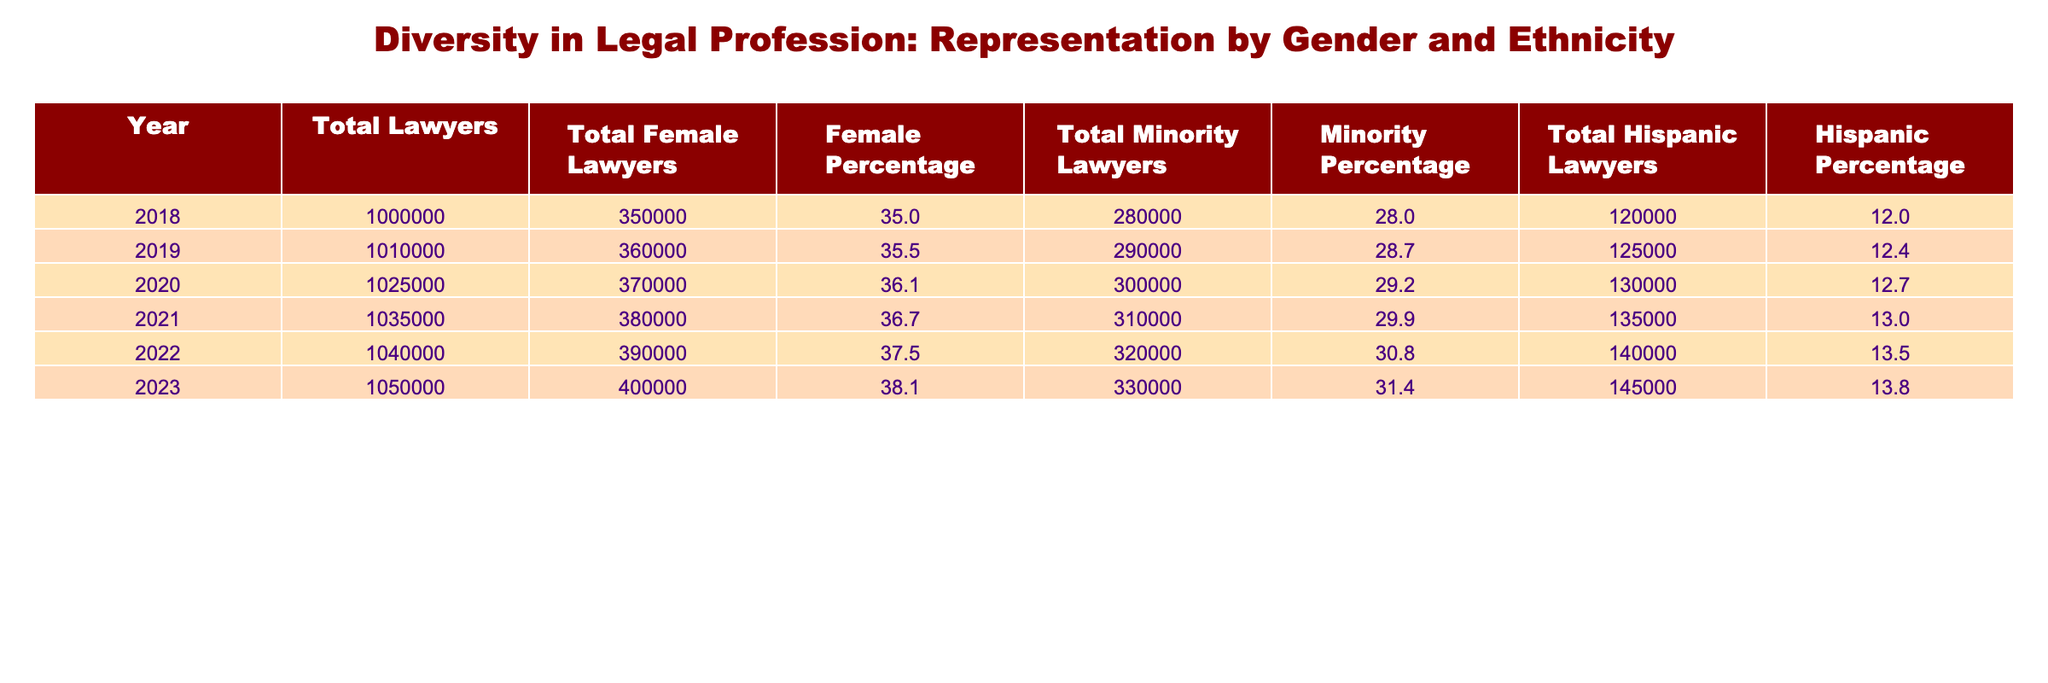What was the total number of minority lawyers in 2020? In 2020, the table shows the total number of minority lawyers as 300,000.
Answer: 300,000 What percentage of total lawyers were female in 2021? The female percentage for total lawyers in 2021 is directly provided in the table, which states 36.7%.
Answer: 36.7% How many more female lawyers were there in 2023 compared to 2018? In 2023, there were 400,000 female lawyers, and in 2018 there were 350,000. The difference is 400,000 - 350,000 = 50,000.
Answer: 50,000 What is the average percentage of Hispanic lawyers from 2018 to 2023? To find the average, first sum the Hispanic percentages: 12.0 + 12.4 + 12.7 + 13.0 + 13.5 + 13.8 = 78.4. Then, divide by the number of years (6): 78.4 / 6 = 13.07.
Answer: 13.07 Is the minority percentage in 2022 greater than in 2021? The minority percentage in 2021 is 29.9%, and in 2022, it is 30.8%. Since 30.8% is greater than 29.9%, the statement is true.
Answer: Yes What was the growth in the total number of lawyers from 2018 to 2023? In 2018, there were 1,000,000 total lawyers, and in 2023 there were 1,050,000. The growth is 1,050,000 - 1,000,000 = 50,000.
Answer: 50,000 Did the total number of minority lawyers increase every year from 2018 to 2023? The table shows that the total number of minority lawyers increased each year, from 280,000 in 2018 to 330,000 in 2023. Thus, the statement is true.
Answer: Yes What is the total percentage of female lawyers in 2019 and 2020 combined? The total percentage of female lawyers in 2019 is 35.5% and in 2020 is 36.1%. To combine, we can total the percentages: 35.5 + 36.1 = 71.6 and since we're discussing two years, they can be viewed as 71.6% over two years.
Answer: 71.6 What was the increase in Hispanic lawyers from 2021 to 2023? In 2021, there were 135,000 Hispanic lawyers and in 2023, there were 145,000. The increase is 145,000 - 135,000 = 10,000.
Answer: 10,000 